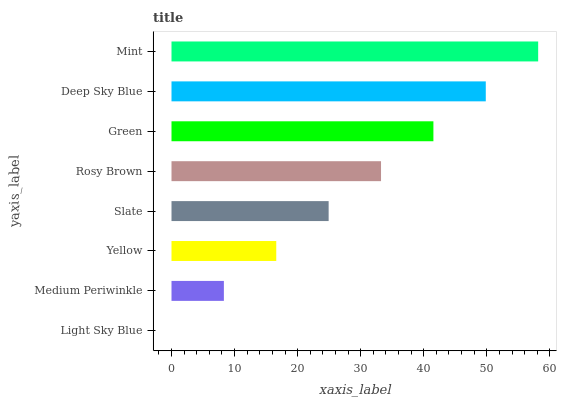Is Light Sky Blue the minimum?
Answer yes or no. Yes. Is Mint the maximum?
Answer yes or no. Yes. Is Medium Periwinkle the minimum?
Answer yes or no. No. Is Medium Periwinkle the maximum?
Answer yes or no. No. Is Medium Periwinkle greater than Light Sky Blue?
Answer yes or no. Yes. Is Light Sky Blue less than Medium Periwinkle?
Answer yes or no. Yes. Is Light Sky Blue greater than Medium Periwinkle?
Answer yes or no. No. Is Medium Periwinkle less than Light Sky Blue?
Answer yes or no. No. Is Rosy Brown the high median?
Answer yes or no. Yes. Is Slate the low median?
Answer yes or no. Yes. Is Deep Sky Blue the high median?
Answer yes or no. No. Is Rosy Brown the low median?
Answer yes or no. No. 